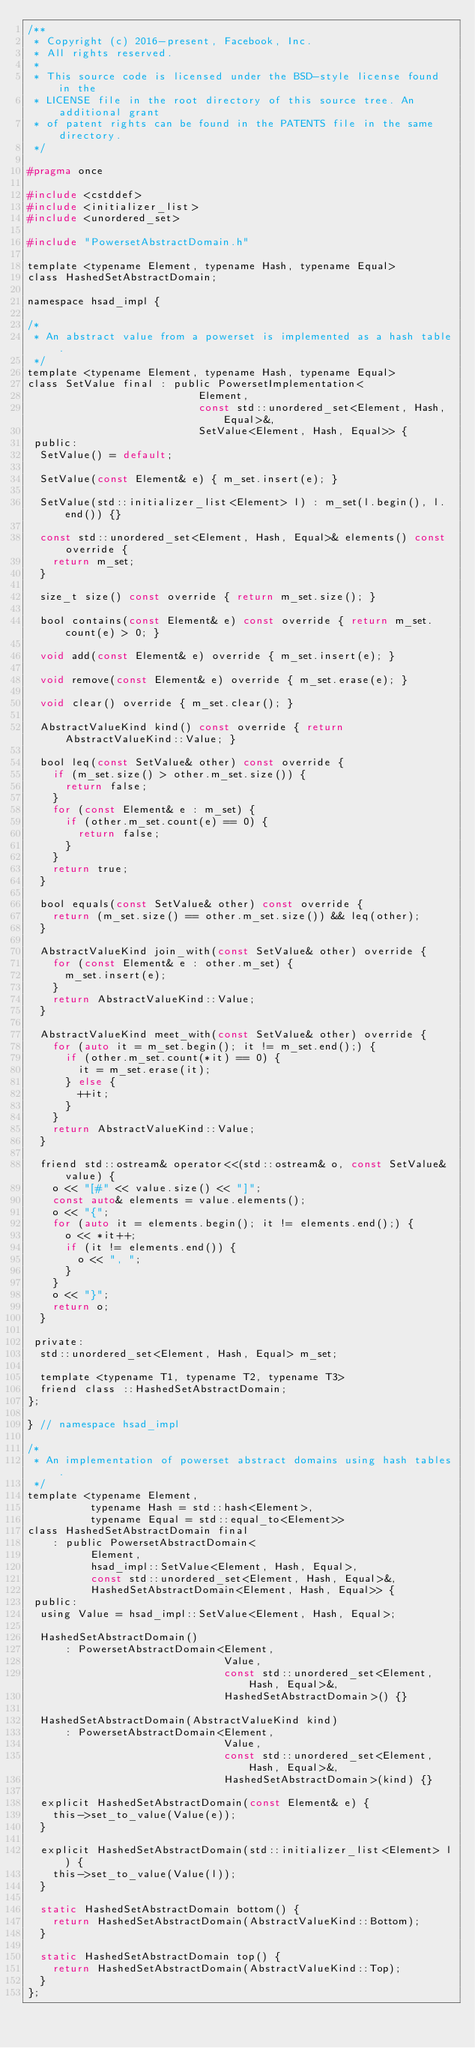Convert code to text. <code><loc_0><loc_0><loc_500><loc_500><_C_>/**
 * Copyright (c) 2016-present, Facebook, Inc.
 * All rights reserved.
 *
 * This source code is licensed under the BSD-style license found in the
 * LICENSE file in the root directory of this source tree. An additional grant
 * of patent rights can be found in the PATENTS file in the same directory.
 */

#pragma once

#include <cstddef>
#include <initializer_list>
#include <unordered_set>

#include "PowersetAbstractDomain.h"

template <typename Element, typename Hash, typename Equal>
class HashedSetAbstractDomain;

namespace hsad_impl {

/*
 * An abstract value from a powerset is implemented as a hash table.
 */
template <typename Element, typename Hash, typename Equal>
class SetValue final : public PowersetImplementation<
                           Element,
                           const std::unordered_set<Element, Hash, Equal>&,
                           SetValue<Element, Hash, Equal>> {
 public:
  SetValue() = default;

  SetValue(const Element& e) { m_set.insert(e); }

  SetValue(std::initializer_list<Element> l) : m_set(l.begin(), l.end()) {}

  const std::unordered_set<Element, Hash, Equal>& elements() const override {
    return m_set;
  }

  size_t size() const override { return m_set.size(); }

  bool contains(const Element& e) const override { return m_set.count(e) > 0; }

  void add(const Element& e) override { m_set.insert(e); }

  void remove(const Element& e) override { m_set.erase(e); }

  void clear() override { m_set.clear(); }

  AbstractValueKind kind() const override { return AbstractValueKind::Value; }

  bool leq(const SetValue& other) const override {
    if (m_set.size() > other.m_set.size()) {
      return false;
    }
    for (const Element& e : m_set) {
      if (other.m_set.count(e) == 0) {
        return false;
      }
    }
    return true;
  }

  bool equals(const SetValue& other) const override {
    return (m_set.size() == other.m_set.size()) && leq(other);
  }

  AbstractValueKind join_with(const SetValue& other) override {
    for (const Element& e : other.m_set) {
      m_set.insert(e);
    }
    return AbstractValueKind::Value;
  }

  AbstractValueKind meet_with(const SetValue& other) override {
    for (auto it = m_set.begin(); it != m_set.end();) {
      if (other.m_set.count(*it) == 0) {
        it = m_set.erase(it);
      } else {
        ++it;
      }
    }
    return AbstractValueKind::Value;
  }

  friend std::ostream& operator<<(std::ostream& o, const SetValue& value) {
    o << "[#" << value.size() << "]";
    const auto& elements = value.elements();
    o << "{";
    for (auto it = elements.begin(); it != elements.end();) {
      o << *it++;
      if (it != elements.end()) {
        o << ", ";
      }
    }
    o << "}";
    return o;
  }

 private:
  std::unordered_set<Element, Hash, Equal> m_set;

  template <typename T1, typename T2, typename T3>
  friend class ::HashedSetAbstractDomain;
};

} // namespace hsad_impl

/*
 * An implementation of powerset abstract domains using hash tables.
 */
template <typename Element,
          typename Hash = std::hash<Element>,
          typename Equal = std::equal_to<Element>>
class HashedSetAbstractDomain final
    : public PowersetAbstractDomain<
          Element,
          hsad_impl::SetValue<Element, Hash, Equal>,
          const std::unordered_set<Element, Hash, Equal>&,
          HashedSetAbstractDomain<Element, Hash, Equal>> {
 public:
  using Value = hsad_impl::SetValue<Element, Hash, Equal>;

  HashedSetAbstractDomain()
      : PowersetAbstractDomain<Element,
                               Value,
                               const std::unordered_set<Element, Hash, Equal>&,
                               HashedSetAbstractDomain>() {}

  HashedSetAbstractDomain(AbstractValueKind kind)
      : PowersetAbstractDomain<Element,
                               Value,
                               const std::unordered_set<Element, Hash, Equal>&,
                               HashedSetAbstractDomain>(kind) {}

  explicit HashedSetAbstractDomain(const Element& e) {
    this->set_to_value(Value(e));
  }

  explicit HashedSetAbstractDomain(std::initializer_list<Element> l) {
    this->set_to_value(Value(l));
  }

  static HashedSetAbstractDomain bottom() {
    return HashedSetAbstractDomain(AbstractValueKind::Bottom);
  }

  static HashedSetAbstractDomain top() {
    return HashedSetAbstractDomain(AbstractValueKind::Top);
  }
};
</code> 